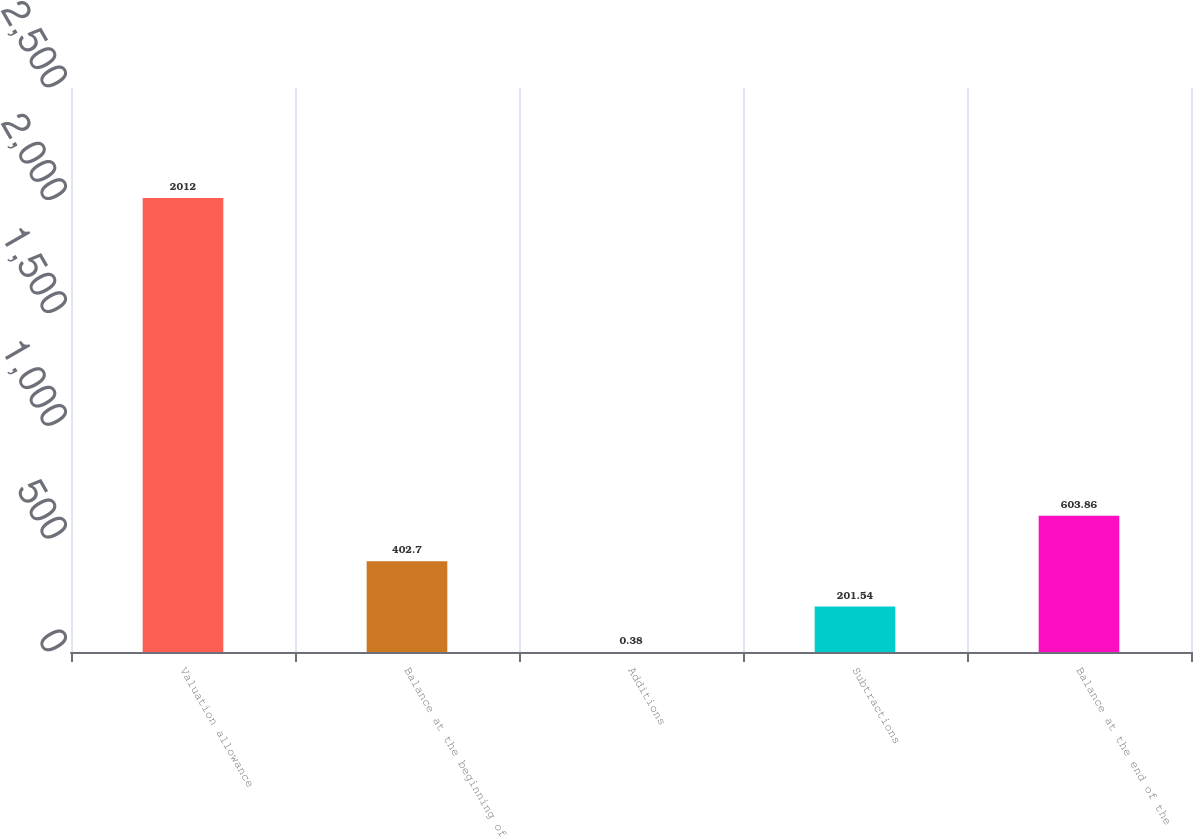Convert chart. <chart><loc_0><loc_0><loc_500><loc_500><bar_chart><fcel>Valuation allowance<fcel>Balance at the beginning of<fcel>Additions<fcel>Subtractions<fcel>Balance at the end of the<nl><fcel>2012<fcel>402.7<fcel>0.38<fcel>201.54<fcel>603.86<nl></chart> 